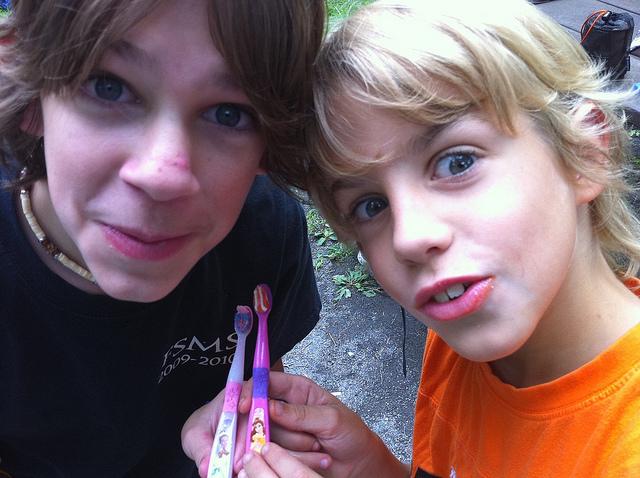Are the boys comparing toothbrushes?
Be succinct. Yes. Are they happy?
Write a very short answer. Yes. What are the boys holding?
Short answer required. Toothbrushes. 